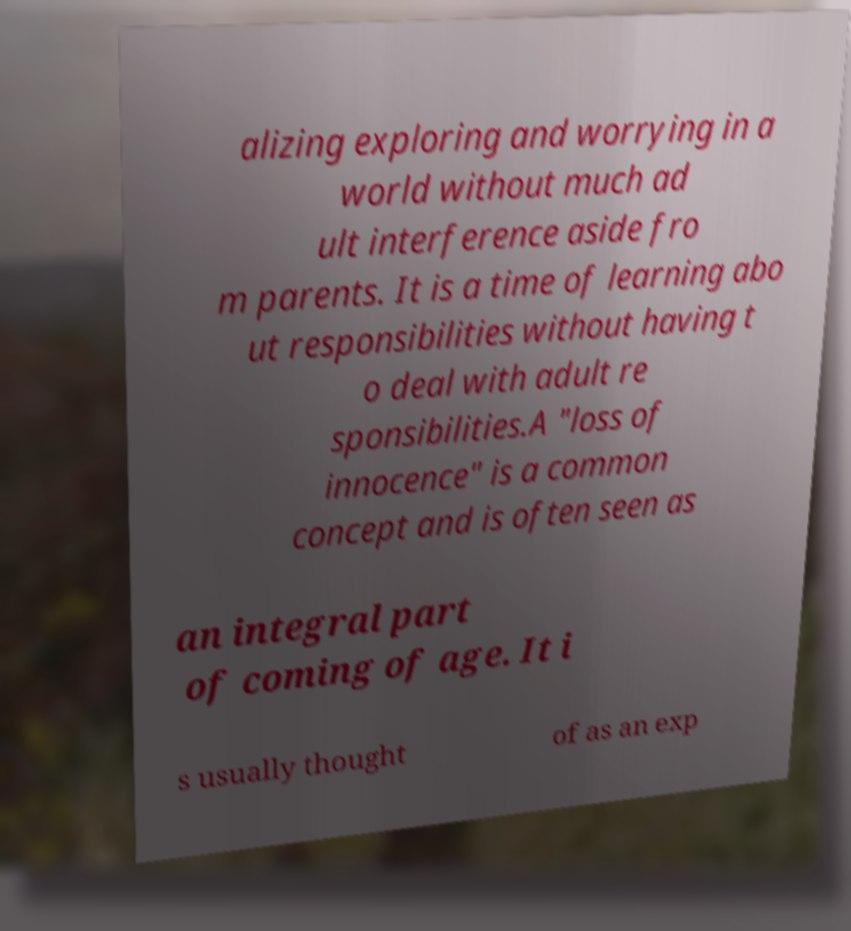What messages or text are displayed in this image? I need them in a readable, typed format. alizing exploring and worrying in a world without much ad ult interference aside fro m parents. It is a time of learning abo ut responsibilities without having t o deal with adult re sponsibilities.A "loss of innocence" is a common concept and is often seen as an integral part of coming of age. It i s usually thought of as an exp 